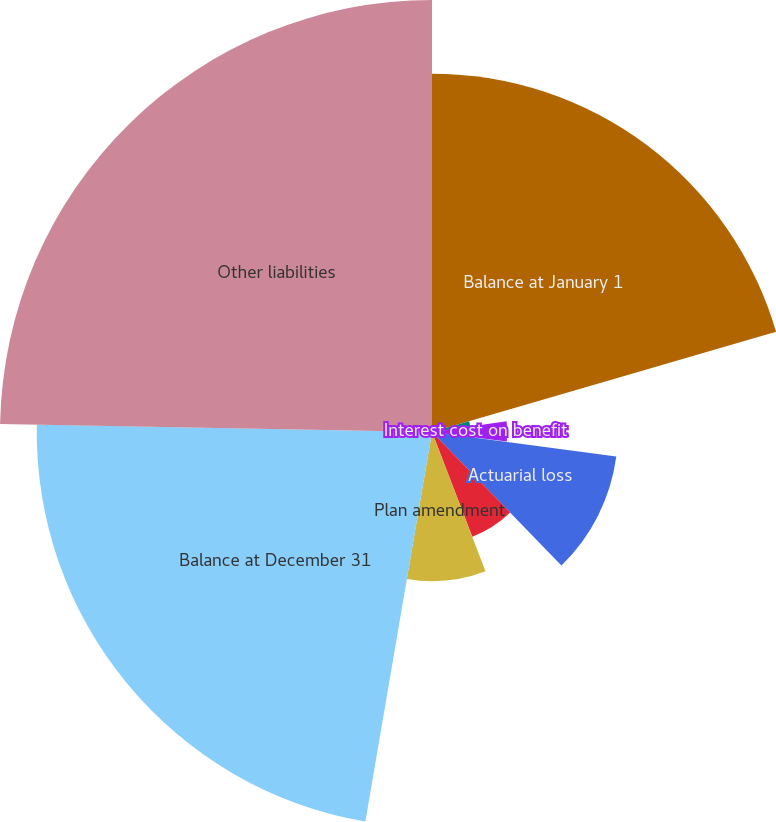Convert chart to OTSL. <chart><loc_0><loc_0><loc_500><loc_500><pie_chart><fcel>Balance at January 1<fcel>Service cost for benefits<fcel>Interest cost on benefit<fcel>Participants contributions<fcel>Actuarial loss<fcel>Benefits paid<fcel>Plan amendment<fcel>Balance at December 31<fcel>Other liabilities<nl><fcel>20.49%<fcel>2.21%<fcel>4.31%<fcel>0.1%<fcel>10.63%<fcel>6.42%<fcel>8.53%<fcel>22.6%<fcel>24.7%<nl></chart> 